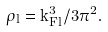Convert formula to latex. <formula><loc_0><loc_0><loc_500><loc_500>\rho _ { l } = { k _ { F l } ^ { 3 } } / { 3 \pi ^ { 2 } } .</formula> 